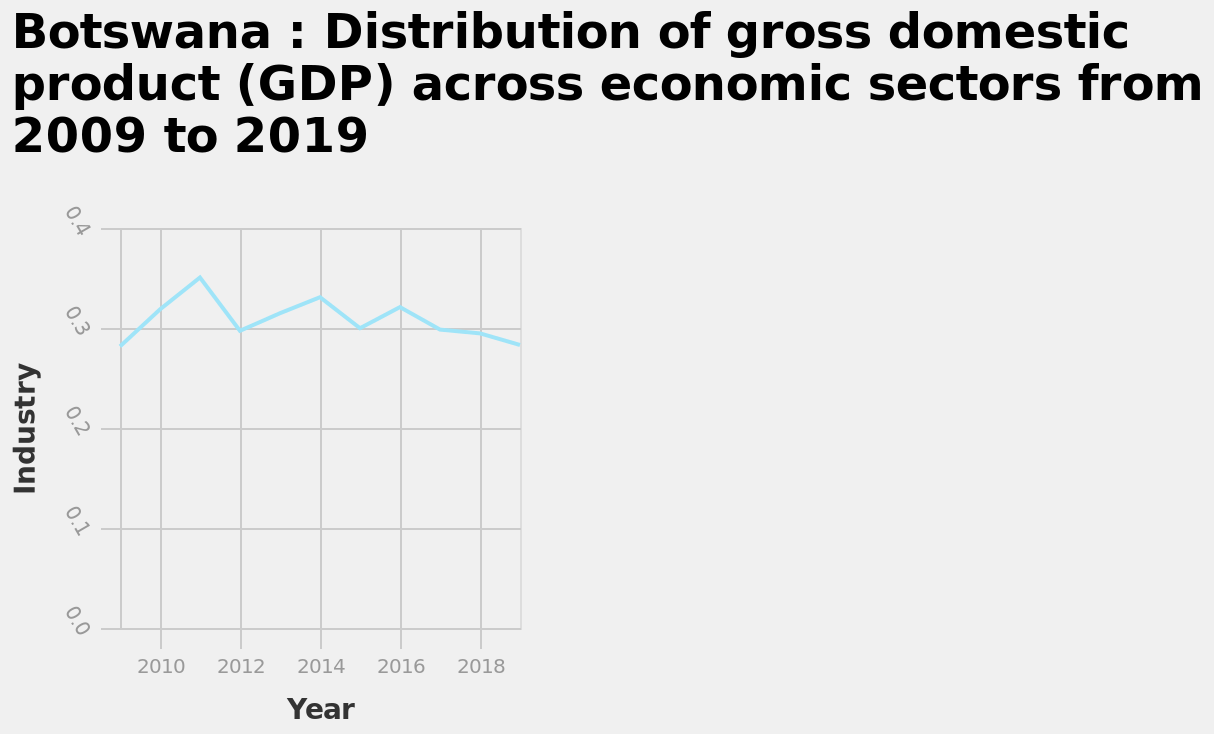<image>
What is labeled on the y-axis? The y-axis is labeled "Industry." In which years did Botswana experience peaks in GDP? Botswana experienced peaks in GDP mostly in 2014 and 2016. 